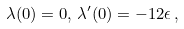<formula> <loc_0><loc_0><loc_500><loc_500>\lambda ( 0 ) = 0 , \, \lambda ^ { \prime } ( 0 ) = - 1 2 \epsilon \, ,</formula> 